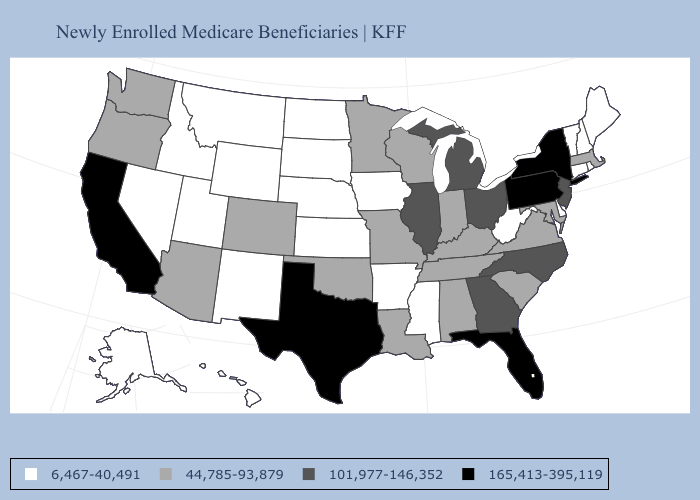Name the states that have a value in the range 6,467-40,491?
Give a very brief answer. Alaska, Arkansas, Connecticut, Delaware, Hawaii, Idaho, Iowa, Kansas, Maine, Mississippi, Montana, Nebraska, Nevada, New Hampshire, New Mexico, North Dakota, Rhode Island, South Dakota, Utah, Vermont, West Virginia, Wyoming. Which states hav the highest value in the Northeast?
Concise answer only. New York, Pennsylvania. What is the value of North Dakota?
Give a very brief answer. 6,467-40,491. Does the map have missing data?
Write a very short answer. No. Among the states that border Missouri , which have the lowest value?
Be succinct. Arkansas, Iowa, Kansas, Nebraska. What is the lowest value in the West?
Answer briefly. 6,467-40,491. What is the value of Minnesota?
Quick response, please. 44,785-93,879. Does Connecticut have the lowest value in the USA?
Quick response, please. Yes. Which states hav the highest value in the South?
Give a very brief answer. Florida, Texas. Name the states that have a value in the range 101,977-146,352?
Give a very brief answer. Georgia, Illinois, Michigan, New Jersey, North Carolina, Ohio. Name the states that have a value in the range 6,467-40,491?
Concise answer only. Alaska, Arkansas, Connecticut, Delaware, Hawaii, Idaho, Iowa, Kansas, Maine, Mississippi, Montana, Nebraska, Nevada, New Hampshire, New Mexico, North Dakota, Rhode Island, South Dakota, Utah, Vermont, West Virginia, Wyoming. How many symbols are there in the legend?
Short answer required. 4. Which states have the highest value in the USA?
Answer briefly. California, Florida, New York, Pennsylvania, Texas. Name the states that have a value in the range 44,785-93,879?
Be succinct. Alabama, Arizona, Colorado, Indiana, Kentucky, Louisiana, Maryland, Massachusetts, Minnesota, Missouri, Oklahoma, Oregon, South Carolina, Tennessee, Virginia, Washington, Wisconsin. 